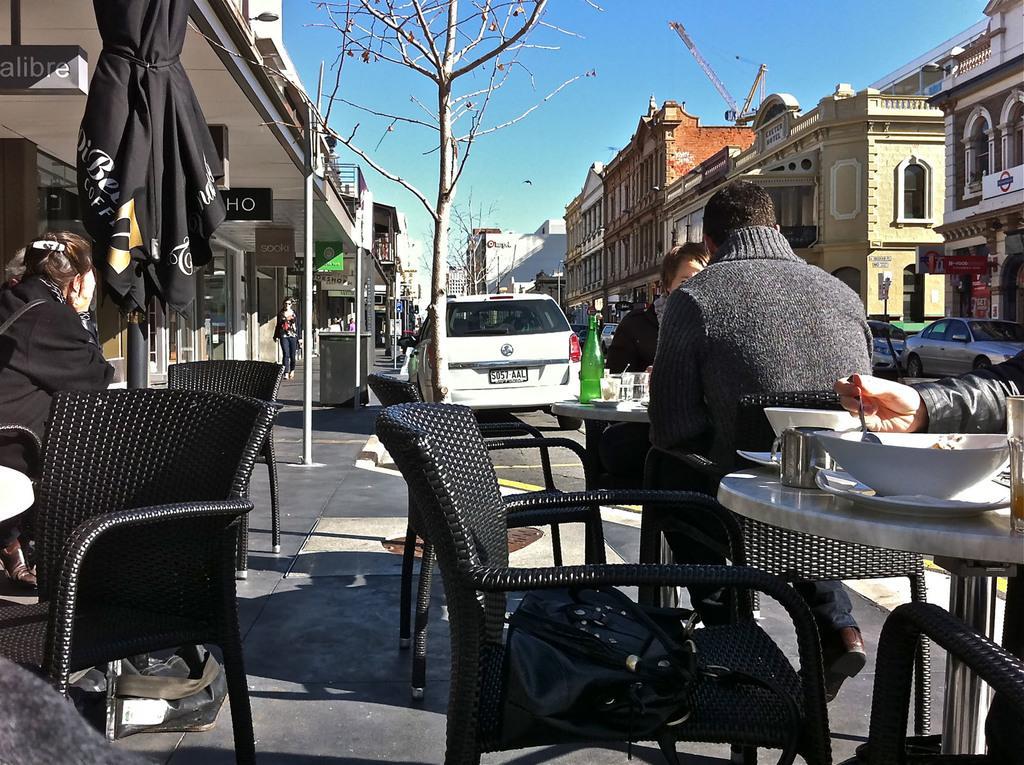Describe this image in one or two sentences. Few people are sitting in a restaurant beside a road with a white car at a distance. 